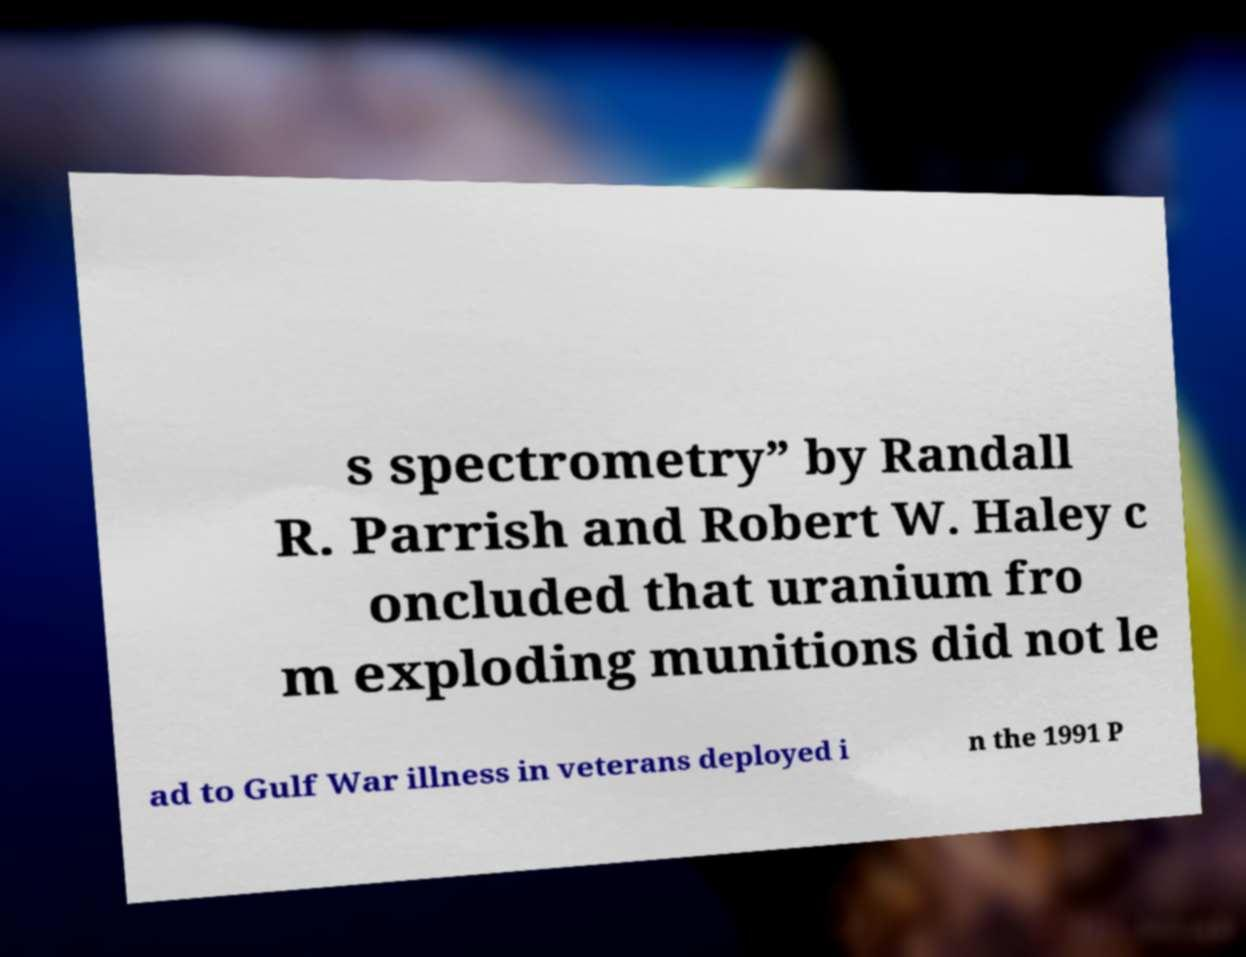There's text embedded in this image that I need extracted. Can you transcribe it verbatim? s spectrometry” by Randall R. Parrish and Robert W. Haley c oncluded that uranium fro m exploding munitions did not le ad to Gulf War illness in veterans deployed i n the 1991 P 